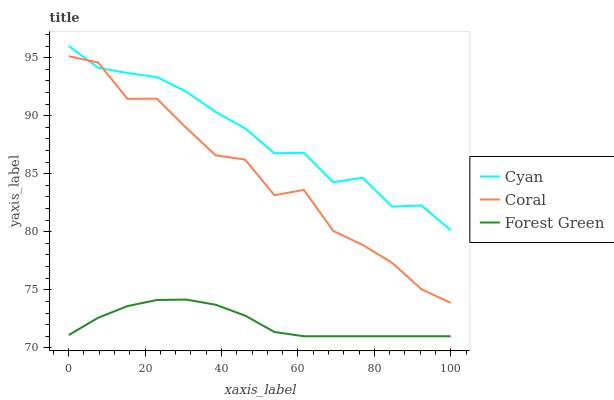Does Forest Green have the minimum area under the curve?
Answer yes or no. Yes. Does Cyan have the maximum area under the curve?
Answer yes or no. Yes. Does Coral have the minimum area under the curve?
Answer yes or no. No. Does Coral have the maximum area under the curve?
Answer yes or no. No. Is Forest Green the smoothest?
Answer yes or no. Yes. Is Coral the roughest?
Answer yes or no. Yes. Is Coral the smoothest?
Answer yes or no. No. Is Forest Green the roughest?
Answer yes or no. No. Does Forest Green have the lowest value?
Answer yes or no. Yes. Does Coral have the lowest value?
Answer yes or no. No. Does Cyan have the highest value?
Answer yes or no. Yes. Does Coral have the highest value?
Answer yes or no. No. Is Forest Green less than Coral?
Answer yes or no. Yes. Is Coral greater than Forest Green?
Answer yes or no. Yes. Does Coral intersect Cyan?
Answer yes or no. Yes. Is Coral less than Cyan?
Answer yes or no. No. Is Coral greater than Cyan?
Answer yes or no. No. Does Forest Green intersect Coral?
Answer yes or no. No. 